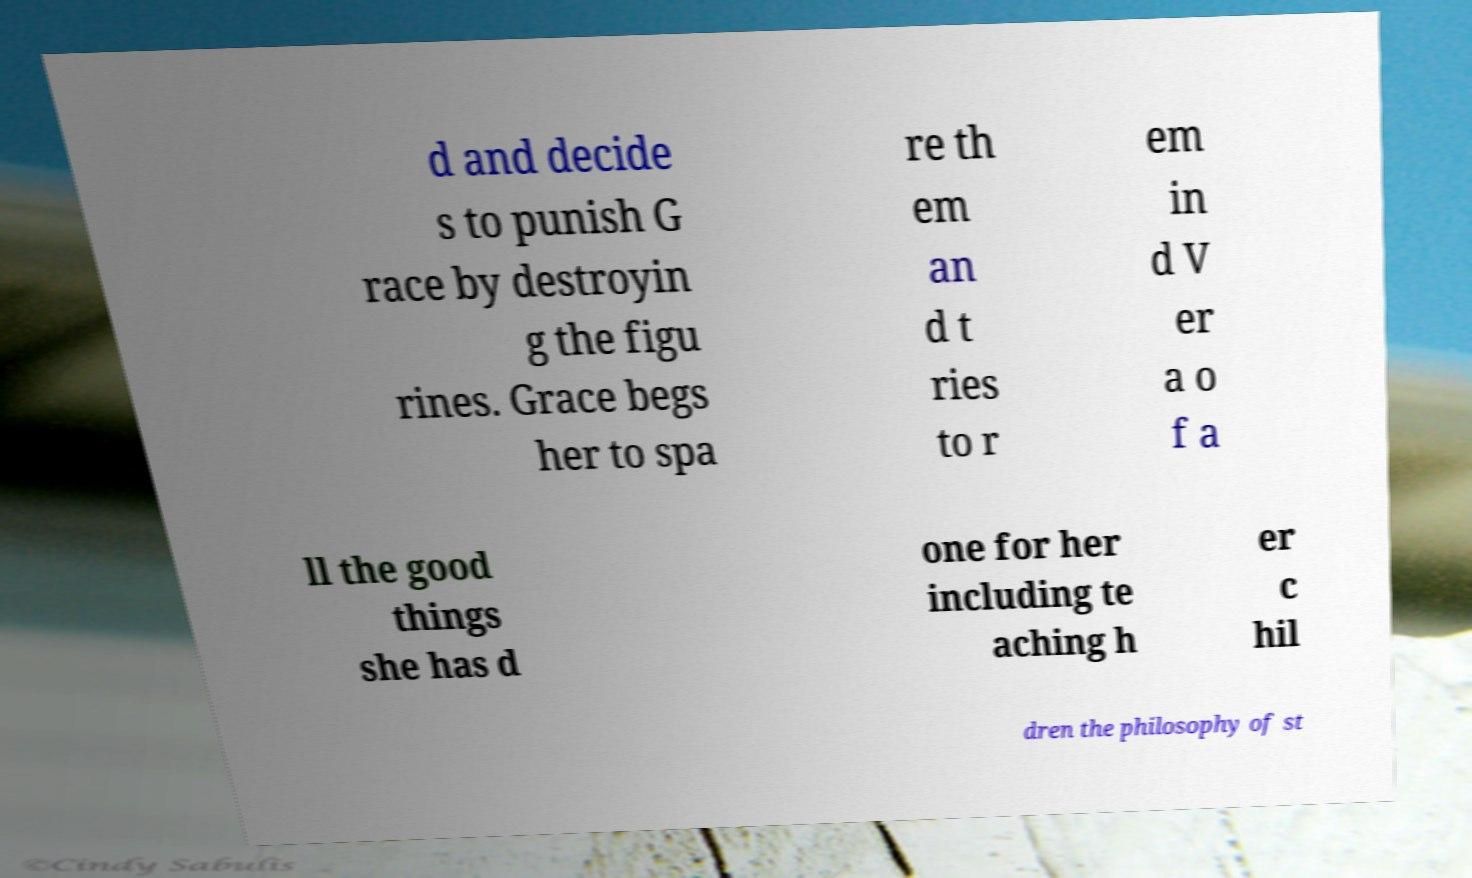For documentation purposes, I need the text within this image transcribed. Could you provide that? d and decide s to punish G race by destroyin g the figu rines. Grace begs her to spa re th em an d t ries to r em in d V er a o f a ll the good things she has d one for her including te aching h er c hil dren the philosophy of st 